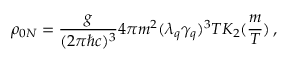Convert formula to latex. <formula><loc_0><loc_0><loc_500><loc_500>\rho _ { 0 N } = \frac { g } { ( 2 \pi \hbar { c } ) ^ { 3 } } 4 \pi m ^ { 2 } ( \lambda _ { q } \gamma _ { q } ) ^ { 3 } T K _ { 2 } ( \frac { m } { T } ) \, ,</formula> 